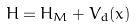Convert formula to latex. <formula><loc_0><loc_0><loc_500><loc_500>H = H _ { M } + V _ { d } ( x )</formula> 